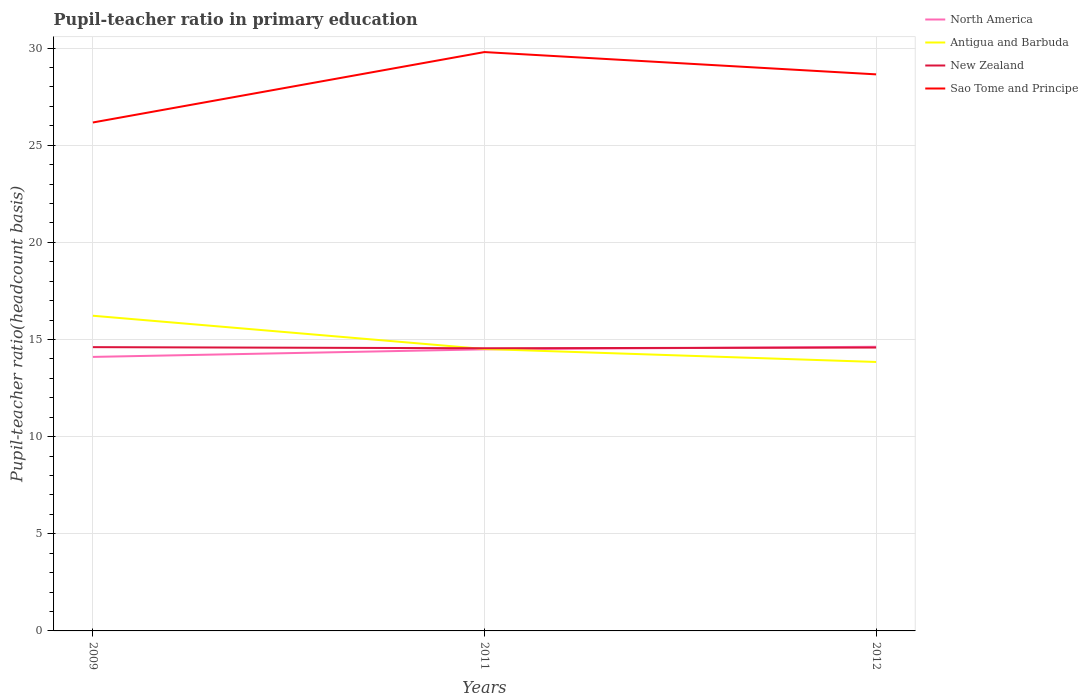Does the line corresponding to Sao Tome and Principe intersect with the line corresponding to Antigua and Barbuda?
Your answer should be compact. No. Across all years, what is the maximum pupil-teacher ratio in primary education in Sao Tome and Principe?
Ensure brevity in your answer.  26.17. What is the total pupil-teacher ratio in primary education in Antigua and Barbuda in the graph?
Offer a terse response. 1.71. What is the difference between the highest and the second highest pupil-teacher ratio in primary education in New Zealand?
Your response must be concise. 0.06. What is the difference between the highest and the lowest pupil-teacher ratio in primary education in Sao Tome and Principe?
Offer a very short reply. 2. Is the pupil-teacher ratio in primary education in Sao Tome and Principe strictly greater than the pupil-teacher ratio in primary education in Antigua and Barbuda over the years?
Offer a terse response. No. How many years are there in the graph?
Ensure brevity in your answer.  3. Are the values on the major ticks of Y-axis written in scientific E-notation?
Keep it short and to the point. No. Does the graph contain grids?
Your answer should be compact. Yes. Where does the legend appear in the graph?
Keep it short and to the point. Top right. How many legend labels are there?
Make the answer very short. 4. How are the legend labels stacked?
Your response must be concise. Vertical. What is the title of the graph?
Give a very brief answer. Pupil-teacher ratio in primary education. Does "Tuvalu" appear as one of the legend labels in the graph?
Your answer should be very brief. No. What is the label or title of the X-axis?
Keep it short and to the point. Years. What is the label or title of the Y-axis?
Provide a succinct answer. Pupil-teacher ratio(headcount basis). What is the Pupil-teacher ratio(headcount basis) in North America in 2009?
Your answer should be compact. 14.11. What is the Pupil-teacher ratio(headcount basis) in Antigua and Barbuda in 2009?
Provide a succinct answer. 16.22. What is the Pupil-teacher ratio(headcount basis) of New Zealand in 2009?
Your response must be concise. 14.61. What is the Pupil-teacher ratio(headcount basis) in Sao Tome and Principe in 2009?
Give a very brief answer. 26.17. What is the Pupil-teacher ratio(headcount basis) of North America in 2011?
Provide a short and direct response. 14.49. What is the Pupil-teacher ratio(headcount basis) of Antigua and Barbuda in 2011?
Offer a very short reply. 14.51. What is the Pupil-teacher ratio(headcount basis) of New Zealand in 2011?
Ensure brevity in your answer.  14.55. What is the Pupil-teacher ratio(headcount basis) of Sao Tome and Principe in 2011?
Make the answer very short. 29.8. What is the Pupil-teacher ratio(headcount basis) in North America in 2012?
Your answer should be compact. 14.63. What is the Pupil-teacher ratio(headcount basis) in Antigua and Barbuda in 2012?
Ensure brevity in your answer.  13.85. What is the Pupil-teacher ratio(headcount basis) of New Zealand in 2012?
Give a very brief answer. 14.59. What is the Pupil-teacher ratio(headcount basis) of Sao Tome and Principe in 2012?
Offer a very short reply. 28.65. Across all years, what is the maximum Pupil-teacher ratio(headcount basis) in North America?
Ensure brevity in your answer.  14.63. Across all years, what is the maximum Pupil-teacher ratio(headcount basis) of Antigua and Barbuda?
Provide a short and direct response. 16.22. Across all years, what is the maximum Pupil-teacher ratio(headcount basis) of New Zealand?
Provide a short and direct response. 14.61. Across all years, what is the maximum Pupil-teacher ratio(headcount basis) of Sao Tome and Principe?
Your answer should be compact. 29.8. Across all years, what is the minimum Pupil-teacher ratio(headcount basis) in North America?
Your response must be concise. 14.11. Across all years, what is the minimum Pupil-teacher ratio(headcount basis) of Antigua and Barbuda?
Ensure brevity in your answer.  13.85. Across all years, what is the minimum Pupil-teacher ratio(headcount basis) of New Zealand?
Give a very brief answer. 14.55. Across all years, what is the minimum Pupil-teacher ratio(headcount basis) in Sao Tome and Principe?
Make the answer very short. 26.17. What is the total Pupil-teacher ratio(headcount basis) of North America in the graph?
Your answer should be compact. 43.23. What is the total Pupil-teacher ratio(headcount basis) in Antigua and Barbuda in the graph?
Your response must be concise. 44.58. What is the total Pupil-teacher ratio(headcount basis) in New Zealand in the graph?
Your answer should be compact. 43.75. What is the total Pupil-teacher ratio(headcount basis) in Sao Tome and Principe in the graph?
Keep it short and to the point. 84.62. What is the difference between the Pupil-teacher ratio(headcount basis) in North America in 2009 and that in 2011?
Provide a short and direct response. -0.39. What is the difference between the Pupil-teacher ratio(headcount basis) of Antigua and Barbuda in 2009 and that in 2011?
Your answer should be very brief. 1.71. What is the difference between the Pupil-teacher ratio(headcount basis) in New Zealand in 2009 and that in 2011?
Offer a terse response. 0.06. What is the difference between the Pupil-teacher ratio(headcount basis) of Sao Tome and Principe in 2009 and that in 2011?
Your answer should be compact. -3.62. What is the difference between the Pupil-teacher ratio(headcount basis) in North America in 2009 and that in 2012?
Offer a terse response. -0.52. What is the difference between the Pupil-teacher ratio(headcount basis) in Antigua and Barbuda in 2009 and that in 2012?
Your response must be concise. 2.38. What is the difference between the Pupil-teacher ratio(headcount basis) in New Zealand in 2009 and that in 2012?
Ensure brevity in your answer.  0.02. What is the difference between the Pupil-teacher ratio(headcount basis) of Sao Tome and Principe in 2009 and that in 2012?
Your answer should be very brief. -2.48. What is the difference between the Pupil-teacher ratio(headcount basis) of North America in 2011 and that in 2012?
Make the answer very short. -0.13. What is the difference between the Pupil-teacher ratio(headcount basis) in Antigua and Barbuda in 2011 and that in 2012?
Your response must be concise. 0.67. What is the difference between the Pupil-teacher ratio(headcount basis) of New Zealand in 2011 and that in 2012?
Provide a succinct answer. -0.04. What is the difference between the Pupil-teacher ratio(headcount basis) in Sao Tome and Principe in 2011 and that in 2012?
Your answer should be very brief. 1.15. What is the difference between the Pupil-teacher ratio(headcount basis) in North America in 2009 and the Pupil-teacher ratio(headcount basis) in Antigua and Barbuda in 2011?
Provide a short and direct response. -0.41. What is the difference between the Pupil-teacher ratio(headcount basis) in North America in 2009 and the Pupil-teacher ratio(headcount basis) in New Zealand in 2011?
Make the answer very short. -0.45. What is the difference between the Pupil-teacher ratio(headcount basis) of North America in 2009 and the Pupil-teacher ratio(headcount basis) of Sao Tome and Principe in 2011?
Your answer should be compact. -15.69. What is the difference between the Pupil-teacher ratio(headcount basis) of Antigua and Barbuda in 2009 and the Pupil-teacher ratio(headcount basis) of New Zealand in 2011?
Your answer should be very brief. 1.67. What is the difference between the Pupil-teacher ratio(headcount basis) in Antigua and Barbuda in 2009 and the Pupil-teacher ratio(headcount basis) in Sao Tome and Principe in 2011?
Offer a terse response. -13.57. What is the difference between the Pupil-teacher ratio(headcount basis) of New Zealand in 2009 and the Pupil-teacher ratio(headcount basis) of Sao Tome and Principe in 2011?
Give a very brief answer. -15.19. What is the difference between the Pupil-teacher ratio(headcount basis) of North America in 2009 and the Pupil-teacher ratio(headcount basis) of Antigua and Barbuda in 2012?
Give a very brief answer. 0.26. What is the difference between the Pupil-teacher ratio(headcount basis) in North America in 2009 and the Pupil-teacher ratio(headcount basis) in New Zealand in 2012?
Provide a short and direct response. -0.48. What is the difference between the Pupil-teacher ratio(headcount basis) of North America in 2009 and the Pupil-teacher ratio(headcount basis) of Sao Tome and Principe in 2012?
Your answer should be compact. -14.54. What is the difference between the Pupil-teacher ratio(headcount basis) of Antigua and Barbuda in 2009 and the Pupil-teacher ratio(headcount basis) of New Zealand in 2012?
Ensure brevity in your answer.  1.64. What is the difference between the Pupil-teacher ratio(headcount basis) in Antigua and Barbuda in 2009 and the Pupil-teacher ratio(headcount basis) in Sao Tome and Principe in 2012?
Provide a succinct answer. -12.43. What is the difference between the Pupil-teacher ratio(headcount basis) of New Zealand in 2009 and the Pupil-teacher ratio(headcount basis) of Sao Tome and Principe in 2012?
Offer a terse response. -14.04. What is the difference between the Pupil-teacher ratio(headcount basis) of North America in 2011 and the Pupil-teacher ratio(headcount basis) of Antigua and Barbuda in 2012?
Your answer should be compact. 0.65. What is the difference between the Pupil-teacher ratio(headcount basis) in North America in 2011 and the Pupil-teacher ratio(headcount basis) in New Zealand in 2012?
Offer a terse response. -0.09. What is the difference between the Pupil-teacher ratio(headcount basis) in North America in 2011 and the Pupil-teacher ratio(headcount basis) in Sao Tome and Principe in 2012?
Offer a terse response. -14.16. What is the difference between the Pupil-teacher ratio(headcount basis) of Antigua and Barbuda in 2011 and the Pupil-teacher ratio(headcount basis) of New Zealand in 2012?
Make the answer very short. -0.07. What is the difference between the Pupil-teacher ratio(headcount basis) of Antigua and Barbuda in 2011 and the Pupil-teacher ratio(headcount basis) of Sao Tome and Principe in 2012?
Make the answer very short. -14.14. What is the difference between the Pupil-teacher ratio(headcount basis) in New Zealand in 2011 and the Pupil-teacher ratio(headcount basis) in Sao Tome and Principe in 2012?
Keep it short and to the point. -14.1. What is the average Pupil-teacher ratio(headcount basis) of North America per year?
Provide a short and direct response. 14.41. What is the average Pupil-teacher ratio(headcount basis) in Antigua and Barbuda per year?
Keep it short and to the point. 14.86. What is the average Pupil-teacher ratio(headcount basis) in New Zealand per year?
Give a very brief answer. 14.58. What is the average Pupil-teacher ratio(headcount basis) of Sao Tome and Principe per year?
Offer a terse response. 28.21. In the year 2009, what is the difference between the Pupil-teacher ratio(headcount basis) in North America and Pupil-teacher ratio(headcount basis) in Antigua and Barbuda?
Your answer should be compact. -2.12. In the year 2009, what is the difference between the Pupil-teacher ratio(headcount basis) of North America and Pupil-teacher ratio(headcount basis) of New Zealand?
Provide a succinct answer. -0.5. In the year 2009, what is the difference between the Pupil-teacher ratio(headcount basis) in North America and Pupil-teacher ratio(headcount basis) in Sao Tome and Principe?
Your answer should be compact. -12.07. In the year 2009, what is the difference between the Pupil-teacher ratio(headcount basis) in Antigua and Barbuda and Pupil-teacher ratio(headcount basis) in New Zealand?
Make the answer very short. 1.62. In the year 2009, what is the difference between the Pupil-teacher ratio(headcount basis) of Antigua and Barbuda and Pupil-teacher ratio(headcount basis) of Sao Tome and Principe?
Give a very brief answer. -9.95. In the year 2009, what is the difference between the Pupil-teacher ratio(headcount basis) of New Zealand and Pupil-teacher ratio(headcount basis) of Sao Tome and Principe?
Ensure brevity in your answer.  -11.56. In the year 2011, what is the difference between the Pupil-teacher ratio(headcount basis) in North America and Pupil-teacher ratio(headcount basis) in Antigua and Barbuda?
Make the answer very short. -0.02. In the year 2011, what is the difference between the Pupil-teacher ratio(headcount basis) of North America and Pupil-teacher ratio(headcount basis) of New Zealand?
Offer a terse response. -0.06. In the year 2011, what is the difference between the Pupil-teacher ratio(headcount basis) in North America and Pupil-teacher ratio(headcount basis) in Sao Tome and Principe?
Make the answer very short. -15.3. In the year 2011, what is the difference between the Pupil-teacher ratio(headcount basis) in Antigua and Barbuda and Pupil-teacher ratio(headcount basis) in New Zealand?
Make the answer very short. -0.04. In the year 2011, what is the difference between the Pupil-teacher ratio(headcount basis) of Antigua and Barbuda and Pupil-teacher ratio(headcount basis) of Sao Tome and Principe?
Keep it short and to the point. -15.29. In the year 2011, what is the difference between the Pupil-teacher ratio(headcount basis) of New Zealand and Pupil-teacher ratio(headcount basis) of Sao Tome and Principe?
Provide a succinct answer. -15.25. In the year 2012, what is the difference between the Pupil-teacher ratio(headcount basis) of North America and Pupil-teacher ratio(headcount basis) of Antigua and Barbuda?
Your response must be concise. 0.78. In the year 2012, what is the difference between the Pupil-teacher ratio(headcount basis) of North America and Pupil-teacher ratio(headcount basis) of New Zealand?
Offer a very short reply. 0.04. In the year 2012, what is the difference between the Pupil-teacher ratio(headcount basis) in North America and Pupil-teacher ratio(headcount basis) in Sao Tome and Principe?
Your response must be concise. -14.02. In the year 2012, what is the difference between the Pupil-teacher ratio(headcount basis) in Antigua and Barbuda and Pupil-teacher ratio(headcount basis) in New Zealand?
Offer a terse response. -0.74. In the year 2012, what is the difference between the Pupil-teacher ratio(headcount basis) of Antigua and Barbuda and Pupil-teacher ratio(headcount basis) of Sao Tome and Principe?
Your answer should be very brief. -14.8. In the year 2012, what is the difference between the Pupil-teacher ratio(headcount basis) of New Zealand and Pupil-teacher ratio(headcount basis) of Sao Tome and Principe?
Your response must be concise. -14.06. What is the ratio of the Pupil-teacher ratio(headcount basis) in North America in 2009 to that in 2011?
Your response must be concise. 0.97. What is the ratio of the Pupil-teacher ratio(headcount basis) in Antigua and Barbuda in 2009 to that in 2011?
Your answer should be very brief. 1.12. What is the ratio of the Pupil-teacher ratio(headcount basis) in New Zealand in 2009 to that in 2011?
Offer a terse response. 1. What is the ratio of the Pupil-teacher ratio(headcount basis) of Sao Tome and Principe in 2009 to that in 2011?
Give a very brief answer. 0.88. What is the ratio of the Pupil-teacher ratio(headcount basis) in North America in 2009 to that in 2012?
Keep it short and to the point. 0.96. What is the ratio of the Pupil-teacher ratio(headcount basis) in Antigua and Barbuda in 2009 to that in 2012?
Offer a terse response. 1.17. What is the ratio of the Pupil-teacher ratio(headcount basis) of New Zealand in 2009 to that in 2012?
Keep it short and to the point. 1. What is the ratio of the Pupil-teacher ratio(headcount basis) in Sao Tome and Principe in 2009 to that in 2012?
Keep it short and to the point. 0.91. What is the ratio of the Pupil-teacher ratio(headcount basis) of North America in 2011 to that in 2012?
Your answer should be very brief. 0.99. What is the ratio of the Pupil-teacher ratio(headcount basis) in Antigua and Barbuda in 2011 to that in 2012?
Your answer should be compact. 1.05. What is the ratio of the Pupil-teacher ratio(headcount basis) in Sao Tome and Principe in 2011 to that in 2012?
Your response must be concise. 1.04. What is the difference between the highest and the second highest Pupil-teacher ratio(headcount basis) in North America?
Your response must be concise. 0.13. What is the difference between the highest and the second highest Pupil-teacher ratio(headcount basis) of Antigua and Barbuda?
Make the answer very short. 1.71. What is the difference between the highest and the second highest Pupil-teacher ratio(headcount basis) of New Zealand?
Make the answer very short. 0.02. What is the difference between the highest and the second highest Pupil-teacher ratio(headcount basis) of Sao Tome and Principe?
Provide a succinct answer. 1.15. What is the difference between the highest and the lowest Pupil-teacher ratio(headcount basis) in North America?
Your answer should be very brief. 0.52. What is the difference between the highest and the lowest Pupil-teacher ratio(headcount basis) of Antigua and Barbuda?
Offer a very short reply. 2.38. What is the difference between the highest and the lowest Pupil-teacher ratio(headcount basis) in New Zealand?
Give a very brief answer. 0.06. What is the difference between the highest and the lowest Pupil-teacher ratio(headcount basis) in Sao Tome and Principe?
Give a very brief answer. 3.62. 